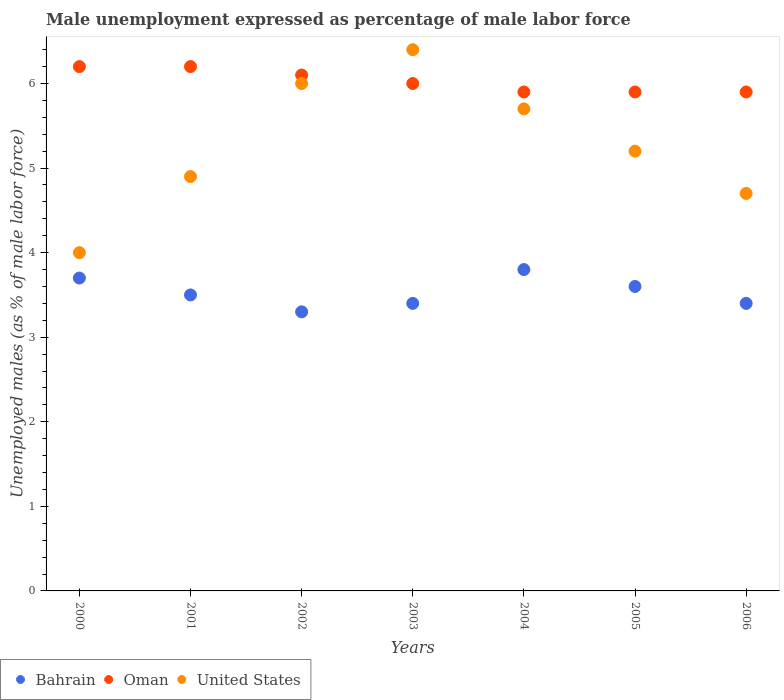How many different coloured dotlines are there?
Your response must be concise. 3. Is the number of dotlines equal to the number of legend labels?
Provide a succinct answer. Yes. What is the unemployment in males in in United States in 2004?
Ensure brevity in your answer.  5.7. Across all years, what is the maximum unemployment in males in in Bahrain?
Give a very brief answer. 3.8. In which year was the unemployment in males in in Bahrain maximum?
Keep it short and to the point. 2004. In which year was the unemployment in males in in Bahrain minimum?
Provide a short and direct response. 2002. What is the total unemployment in males in in Oman in the graph?
Give a very brief answer. 42.2. What is the difference between the unemployment in males in in Bahrain in 2000 and that in 2006?
Your response must be concise. 0.3. What is the difference between the unemployment in males in in Bahrain in 2002 and the unemployment in males in in United States in 2005?
Make the answer very short. -1.9. What is the average unemployment in males in in Oman per year?
Provide a succinct answer. 6.03. In the year 2003, what is the difference between the unemployment in males in in Bahrain and unemployment in males in in United States?
Ensure brevity in your answer.  -3. What is the ratio of the unemployment in males in in United States in 2003 to that in 2006?
Your answer should be compact. 1.36. What is the difference between the highest and the second highest unemployment in males in in United States?
Offer a terse response. 0.4. What is the difference between the highest and the lowest unemployment in males in in Bahrain?
Keep it short and to the point. 0.5. In how many years, is the unemployment in males in in Bahrain greater than the average unemployment in males in in Bahrain taken over all years?
Ensure brevity in your answer.  3. Is the sum of the unemployment in males in in Bahrain in 2003 and 2004 greater than the maximum unemployment in males in in United States across all years?
Offer a terse response. Yes. Is it the case that in every year, the sum of the unemployment in males in in United States and unemployment in males in in Bahrain  is greater than the unemployment in males in in Oman?
Your response must be concise. Yes. Does the unemployment in males in in Bahrain monotonically increase over the years?
Offer a very short reply. No. Is the unemployment in males in in Oman strictly less than the unemployment in males in in United States over the years?
Provide a succinct answer. No. How many dotlines are there?
Provide a short and direct response. 3. How many years are there in the graph?
Keep it short and to the point. 7. What is the difference between two consecutive major ticks on the Y-axis?
Make the answer very short. 1. How many legend labels are there?
Offer a very short reply. 3. How are the legend labels stacked?
Provide a short and direct response. Horizontal. What is the title of the graph?
Your answer should be very brief. Male unemployment expressed as percentage of male labor force. What is the label or title of the Y-axis?
Provide a short and direct response. Unemployed males (as % of male labor force). What is the Unemployed males (as % of male labor force) in Bahrain in 2000?
Your answer should be very brief. 3.7. What is the Unemployed males (as % of male labor force) of Oman in 2000?
Keep it short and to the point. 6.2. What is the Unemployed males (as % of male labor force) of Bahrain in 2001?
Offer a terse response. 3.5. What is the Unemployed males (as % of male labor force) in Oman in 2001?
Make the answer very short. 6.2. What is the Unemployed males (as % of male labor force) of United States in 2001?
Make the answer very short. 4.9. What is the Unemployed males (as % of male labor force) of Bahrain in 2002?
Keep it short and to the point. 3.3. What is the Unemployed males (as % of male labor force) in Oman in 2002?
Your answer should be compact. 6.1. What is the Unemployed males (as % of male labor force) of United States in 2002?
Provide a short and direct response. 6. What is the Unemployed males (as % of male labor force) in Bahrain in 2003?
Provide a short and direct response. 3.4. What is the Unemployed males (as % of male labor force) in Oman in 2003?
Offer a terse response. 6. What is the Unemployed males (as % of male labor force) in United States in 2003?
Provide a short and direct response. 6.4. What is the Unemployed males (as % of male labor force) of Bahrain in 2004?
Give a very brief answer. 3.8. What is the Unemployed males (as % of male labor force) in Oman in 2004?
Your response must be concise. 5.9. What is the Unemployed males (as % of male labor force) of United States in 2004?
Give a very brief answer. 5.7. What is the Unemployed males (as % of male labor force) in Bahrain in 2005?
Offer a very short reply. 3.6. What is the Unemployed males (as % of male labor force) in Oman in 2005?
Your response must be concise. 5.9. What is the Unemployed males (as % of male labor force) of United States in 2005?
Your answer should be very brief. 5.2. What is the Unemployed males (as % of male labor force) of Bahrain in 2006?
Keep it short and to the point. 3.4. What is the Unemployed males (as % of male labor force) in Oman in 2006?
Provide a succinct answer. 5.9. What is the Unemployed males (as % of male labor force) in United States in 2006?
Your answer should be very brief. 4.7. Across all years, what is the maximum Unemployed males (as % of male labor force) in Bahrain?
Your answer should be compact. 3.8. Across all years, what is the maximum Unemployed males (as % of male labor force) in Oman?
Ensure brevity in your answer.  6.2. Across all years, what is the maximum Unemployed males (as % of male labor force) in United States?
Provide a succinct answer. 6.4. Across all years, what is the minimum Unemployed males (as % of male labor force) of Bahrain?
Offer a very short reply. 3.3. Across all years, what is the minimum Unemployed males (as % of male labor force) in Oman?
Keep it short and to the point. 5.9. Across all years, what is the minimum Unemployed males (as % of male labor force) of United States?
Offer a terse response. 4. What is the total Unemployed males (as % of male labor force) in Bahrain in the graph?
Your response must be concise. 24.7. What is the total Unemployed males (as % of male labor force) of Oman in the graph?
Offer a terse response. 42.2. What is the total Unemployed males (as % of male labor force) in United States in the graph?
Offer a terse response. 36.9. What is the difference between the Unemployed males (as % of male labor force) in Bahrain in 2000 and that in 2003?
Your answer should be compact. 0.3. What is the difference between the Unemployed males (as % of male labor force) of Oman in 2000 and that in 2003?
Keep it short and to the point. 0.2. What is the difference between the Unemployed males (as % of male labor force) in Oman in 2000 and that in 2004?
Offer a very short reply. 0.3. What is the difference between the Unemployed males (as % of male labor force) of United States in 2000 and that in 2004?
Your response must be concise. -1.7. What is the difference between the Unemployed males (as % of male labor force) in Bahrain in 2000 and that in 2005?
Make the answer very short. 0.1. What is the difference between the Unemployed males (as % of male labor force) in Oman in 2000 and that in 2005?
Your answer should be very brief. 0.3. What is the difference between the Unemployed males (as % of male labor force) of United States in 2000 and that in 2005?
Offer a terse response. -1.2. What is the difference between the Unemployed males (as % of male labor force) of United States in 2000 and that in 2006?
Your answer should be very brief. -0.7. What is the difference between the Unemployed males (as % of male labor force) of Oman in 2001 and that in 2002?
Your answer should be very brief. 0.1. What is the difference between the Unemployed males (as % of male labor force) in United States in 2001 and that in 2002?
Keep it short and to the point. -1.1. What is the difference between the Unemployed males (as % of male labor force) of Bahrain in 2001 and that in 2003?
Your response must be concise. 0.1. What is the difference between the Unemployed males (as % of male labor force) in United States in 2001 and that in 2003?
Your answer should be very brief. -1.5. What is the difference between the Unemployed males (as % of male labor force) of Oman in 2001 and that in 2005?
Your answer should be compact. 0.3. What is the difference between the Unemployed males (as % of male labor force) of United States in 2001 and that in 2006?
Your response must be concise. 0.2. What is the difference between the Unemployed males (as % of male labor force) of Bahrain in 2002 and that in 2003?
Offer a very short reply. -0.1. What is the difference between the Unemployed males (as % of male labor force) in Oman in 2002 and that in 2003?
Offer a very short reply. 0.1. What is the difference between the Unemployed males (as % of male labor force) of United States in 2002 and that in 2003?
Offer a very short reply. -0.4. What is the difference between the Unemployed males (as % of male labor force) of Bahrain in 2002 and that in 2004?
Keep it short and to the point. -0.5. What is the difference between the Unemployed males (as % of male labor force) of United States in 2002 and that in 2004?
Provide a short and direct response. 0.3. What is the difference between the Unemployed males (as % of male labor force) of Bahrain in 2002 and that in 2005?
Make the answer very short. -0.3. What is the difference between the Unemployed males (as % of male labor force) in United States in 2002 and that in 2005?
Your response must be concise. 0.8. What is the difference between the Unemployed males (as % of male labor force) of Oman in 2002 and that in 2006?
Your response must be concise. 0.2. What is the difference between the Unemployed males (as % of male labor force) in Bahrain in 2003 and that in 2004?
Your answer should be very brief. -0.4. What is the difference between the Unemployed males (as % of male labor force) in Oman in 2003 and that in 2004?
Your response must be concise. 0.1. What is the difference between the Unemployed males (as % of male labor force) of United States in 2003 and that in 2005?
Offer a very short reply. 1.2. What is the difference between the Unemployed males (as % of male labor force) of United States in 2003 and that in 2006?
Offer a very short reply. 1.7. What is the difference between the Unemployed males (as % of male labor force) of United States in 2004 and that in 2005?
Provide a succinct answer. 0.5. What is the difference between the Unemployed males (as % of male labor force) in Bahrain in 2004 and that in 2006?
Give a very brief answer. 0.4. What is the difference between the Unemployed males (as % of male labor force) in Oman in 2004 and that in 2006?
Ensure brevity in your answer.  0. What is the difference between the Unemployed males (as % of male labor force) in United States in 2005 and that in 2006?
Offer a terse response. 0.5. What is the difference between the Unemployed males (as % of male labor force) in Bahrain in 2000 and the Unemployed males (as % of male labor force) in Oman in 2002?
Keep it short and to the point. -2.4. What is the difference between the Unemployed males (as % of male labor force) of Bahrain in 2000 and the Unemployed males (as % of male labor force) of United States in 2003?
Give a very brief answer. -2.7. What is the difference between the Unemployed males (as % of male labor force) of Bahrain in 2000 and the Unemployed males (as % of male labor force) of United States in 2004?
Offer a terse response. -2. What is the difference between the Unemployed males (as % of male labor force) in Oman in 2000 and the Unemployed males (as % of male labor force) in United States in 2006?
Provide a succinct answer. 1.5. What is the difference between the Unemployed males (as % of male labor force) in Oman in 2001 and the Unemployed males (as % of male labor force) in United States in 2002?
Provide a succinct answer. 0.2. What is the difference between the Unemployed males (as % of male labor force) of Bahrain in 2001 and the Unemployed males (as % of male labor force) of Oman in 2003?
Ensure brevity in your answer.  -2.5. What is the difference between the Unemployed males (as % of male labor force) in Bahrain in 2001 and the Unemployed males (as % of male labor force) in United States in 2003?
Make the answer very short. -2.9. What is the difference between the Unemployed males (as % of male labor force) of Bahrain in 2001 and the Unemployed males (as % of male labor force) of Oman in 2004?
Make the answer very short. -2.4. What is the difference between the Unemployed males (as % of male labor force) in Bahrain in 2001 and the Unemployed males (as % of male labor force) in United States in 2004?
Your answer should be compact. -2.2. What is the difference between the Unemployed males (as % of male labor force) of Oman in 2001 and the Unemployed males (as % of male labor force) of United States in 2004?
Your answer should be compact. 0.5. What is the difference between the Unemployed males (as % of male labor force) in Bahrain in 2001 and the Unemployed males (as % of male labor force) in Oman in 2005?
Provide a short and direct response. -2.4. What is the difference between the Unemployed males (as % of male labor force) in Oman in 2001 and the Unemployed males (as % of male labor force) in United States in 2006?
Provide a short and direct response. 1.5. What is the difference between the Unemployed males (as % of male labor force) of Bahrain in 2002 and the Unemployed males (as % of male labor force) of Oman in 2003?
Your answer should be very brief. -2.7. What is the difference between the Unemployed males (as % of male labor force) of Bahrain in 2002 and the Unemployed males (as % of male labor force) of United States in 2003?
Your answer should be compact. -3.1. What is the difference between the Unemployed males (as % of male labor force) in Bahrain in 2002 and the Unemployed males (as % of male labor force) in United States in 2004?
Offer a very short reply. -2.4. What is the difference between the Unemployed males (as % of male labor force) in Bahrain in 2002 and the Unemployed males (as % of male labor force) in Oman in 2005?
Provide a short and direct response. -2.6. What is the difference between the Unemployed males (as % of male labor force) in Oman in 2002 and the Unemployed males (as % of male labor force) in United States in 2006?
Offer a very short reply. 1.4. What is the difference between the Unemployed males (as % of male labor force) in Oman in 2003 and the Unemployed males (as % of male labor force) in United States in 2004?
Give a very brief answer. 0.3. What is the difference between the Unemployed males (as % of male labor force) in Bahrain in 2003 and the Unemployed males (as % of male labor force) in United States in 2006?
Your answer should be compact. -1.3. What is the difference between the Unemployed males (as % of male labor force) in Bahrain in 2004 and the Unemployed males (as % of male labor force) in Oman in 2006?
Provide a short and direct response. -2.1. What is the difference between the Unemployed males (as % of male labor force) of Oman in 2004 and the Unemployed males (as % of male labor force) of United States in 2006?
Your answer should be compact. 1.2. What is the difference between the Unemployed males (as % of male labor force) in Bahrain in 2005 and the Unemployed males (as % of male labor force) in Oman in 2006?
Offer a terse response. -2.3. What is the difference between the Unemployed males (as % of male labor force) in Bahrain in 2005 and the Unemployed males (as % of male labor force) in United States in 2006?
Give a very brief answer. -1.1. What is the average Unemployed males (as % of male labor force) in Bahrain per year?
Your answer should be compact. 3.53. What is the average Unemployed males (as % of male labor force) of Oman per year?
Your answer should be very brief. 6.03. What is the average Unemployed males (as % of male labor force) in United States per year?
Make the answer very short. 5.27. In the year 2000, what is the difference between the Unemployed males (as % of male labor force) in Bahrain and Unemployed males (as % of male labor force) in United States?
Keep it short and to the point. -0.3. In the year 2000, what is the difference between the Unemployed males (as % of male labor force) in Oman and Unemployed males (as % of male labor force) in United States?
Offer a very short reply. 2.2. In the year 2001, what is the difference between the Unemployed males (as % of male labor force) in Bahrain and Unemployed males (as % of male labor force) in Oman?
Your response must be concise. -2.7. In the year 2001, what is the difference between the Unemployed males (as % of male labor force) of Oman and Unemployed males (as % of male labor force) of United States?
Your response must be concise. 1.3. In the year 2002, what is the difference between the Unemployed males (as % of male labor force) of Bahrain and Unemployed males (as % of male labor force) of United States?
Make the answer very short. -2.7. In the year 2002, what is the difference between the Unemployed males (as % of male labor force) in Oman and Unemployed males (as % of male labor force) in United States?
Keep it short and to the point. 0.1. In the year 2003, what is the difference between the Unemployed males (as % of male labor force) of Bahrain and Unemployed males (as % of male labor force) of Oman?
Offer a terse response. -2.6. In the year 2003, what is the difference between the Unemployed males (as % of male labor force) of Bahrain and Unemployed males (as % of male labor force) of United States?
Your answer should be very brief. -3. In the year 2003, what is the difference between the Unemployed males (as % of male labor force) in Oman and Unemployed males (as % of male labor force) in United States?
Give a very brief answer. -0.4. In the year 2004, what is the difference between the Unemployed males (as % of male labor force) of Bahrain and Unemployed males (as % of male labor force) of United States?
Your response must be concise. -1.9. In the year 2006, what is the difference between the Unemployed males (as % of male labor force) in Bahrain and Unemployed males (as % of male labor force) in Oman?
Your answer should be very brief. -2.5. In the year 2006, what is the difference between the Unemployed males (as % of male labor force) of Bahrain and Unemployed males (as % of male labor force) of United States?
Ensure brevity in your answer.  -1.3. What is the ratio of the Unemployed males (as % of male labor force) of Bahrain in 2000 to that in 2001?
Give a very brief answer. 1.06. What is the ratio of the Unemployed males (as % of male labor force) in United States in 2000 to that in 2001?
Your answer should be compact. 0.82. What is the ratio of the Unemployed males (as % of male labor force) of Bahrain in 2000 to that in 2002?
Your response must be concise. 1.12. What is the ratio of the Unemployed males (as % of male labor force) in Oman in 2000 to that in 2002?
Make the answer very short. 1.02. What is the ratio of the Unemployed males (as % of male labor force) in Bahrain in 2000 to that in 2003?
Your response must be concise. 1.09. What is the ratio of the Unemployed males (as % of male labor force) of Oman in 2000 to that in 2003?
Offer a terse response. 1.03. What is the ratio of the Unemployed males (as % of male labor force) in Bahrain in 2000 to that in 2004?
Your answer should be very brief. 0.97. What is the ratio of the Unemployed males (as % of male labor force) in Oman in 2000 to that in 2004?
Ensure brevity in your answer.  1.05. What is the ratio of the Unemployed males (as % of male labor force) of United States in 2000 to that in 2004?
Offer a very short reply. 0.7. What is the ratio of the Unemployed males (as % of male labor force) of Bahrain in 2000 to that in 2005?
Offer a very short reply. 1.03. What is the ratio of the Unemployed males (as % of male labor force) in Oman in 2000 to that in 2005?
Offer a very short reply. 1.05. What is the ratio of the Unemployed males (as % of male labor force) in United States in 2000 to that in 2005?
Keep it short and to the point. 0.77. What is the ratio of the Unemployed males (as % of male labor force) of Bahrain in 2000 to that in 2006?
Make the answer very short. 1.09. What is the ratio of the Unemployed males (as % of male labor force) of Oman in 2000 to that in 2006?
Offer a terse response. 1.05. What is the ratio of the Unemployed males (as % of male labor force) of United States in 2000 to that in 2006?
Give a very brief answer. 0.85. What is the ratio of the Unemployed males (as % of male labor force) of Bahrain in 2001 to that in 2002?
Make the answer very short. 1.06. What is the ratio of the Unemployed males (as % of male labor force) in Oman in 2001 to that in 2002?
Your answer should be very brief. 1.02. What is the ratio of the Unemployed males (as % of male labor force) of United States in 2001 to that in 2002?
Provide a succinct answer. 0.82. What is the ratio of the Unemployed males (as % of male labor force) of Bahrain in 2001 to that in 2003?
Provide a succinct answer. 1.03. What is the ratio of the Unemployed males (as % of male labor force) of Oman in 2001 to that in 2003?
Your answer should be very brief. 1.03. What is the ratio of the Unemployed males (as % of male labor force) of United States in 2001 to that in 2003?
Make the answer very short. 0.77. What is the ratio of the Unemployed males (as % of male labor force) in Bahrain in 2001 to that in 2004?
Offer a very short reply. 0.92. What is the ratio of the Unemployed males (as % of male labor force) in Oman in 2001 to that in 2004?
Provide a succinct answer. 1.05. What is the ratio of the Unemployed males (as % of male labor force) of United States in 2001 to that in 2004?
Offer a very short reply. 0.86. What is the ratio of the Unemployed males (as % of male labor force) in Bahrain in 2001 to that in 2005?
Offer a very short reply. 0.97. What is the ratio of the Unemployed males (as % of male labor force) in Oman in 2001 to that in 2005?
Keep it short and to the point. 1.05. What is the ratio of the Unemployed males (as % of male labor force) of United States in 2001 to that in 2005?
Ensure brevity in your answer.  0.94. What is the ratio of the Unemployed males (as % of male labor force) in Bahrain in 2001 to that in 2006?
Provide a succinct answer. 1.03. What is the ratio of the Unemployed males (as % of male labor force) of Oman in 2001 to that in 2006?
Your response must be concise. 1.05. What is the ratio of the Unemployed males (as % of male labor force) of United States in 2001 to that in 2006?
Your response must be concise. 1.04. What is the ratio of the Unemployed males (as % of male labor force) in Bahrain in 2002 to that in 2003?
Offer a terse response. 0.97. What is the ratio of the Unemployed males (as % of male labor force) of Oman in 2002 to that in 2003?
Provide a short and direct response. 1.02. What is the ratio of the Unemployed males (as % of male labor force) of Bahrain in 2002 to that in 2004?
Your response must be concise. 0.87. What is the ratio of the Unemployed males (as % of male labor force) in Oman in 2002 to that in 2004?
Offer a very short reply. 1.03. What is the ratio of the Unemployed males (as % of male labor force) in United States in 2002 to that in 2004?
Give a very brief answer. 1.05. What is the ratio of the Unemployed males (as % of male labor force) in Oman in 2002 to that in 2005?
Keep it short and to the point. 1.03. What is the ratio of the Unemployed males (as % of male labor force) of United States in 2002 to that in 2005?
Your response must be concise. 1.15. What is the ratio of the Unemployed males (as % of male labor force) in Bahrain in 2002 to that in 2006?
Provide a succinct answer. 0.97. What is the ratio of the Unemployed males (as % of male labor force) in Oman in 2002 to that in 2006?
Your answer should be very brief. 1.03. What is the ratio of the Unemployed males (as % of male labor force) in United States in 2002 to that in 2006?
Ensure brevity in your answer.  1.28. What is the ratio of the Unemployed males (as % of male labor force) of Bahrain in 2003 to that in 2004?
Offer a very short reply. 0.89. What is the ratio of the Unemployed males (as % of male labor force) in Oman in 2003 to that in 2004?
Your response must be concise. 1.02. What is the ratio of the Unemployed males (as % of male labor force) in United States in 2003 to that in 2004?
Give a very brief answer. 1.12. What is the ratio of the Unemployed males (as % of male labor force) of Bahrain in 2003 to that in 2005?
Your response must be concise. 0.94. What is the ratio of the Unemployed males (as % of male labor force) of Oman in 2003 to that in 2005?
Offer a terse response. 1.02. What is the ratio of the Unemployed males (as % of male labor force) in United States in 2003 to that in 2005?
Your response must be concise. 1.23. What is the ratio of the Unemployed males (as % of male labor force) of Bahrain in 2003 to that in 2006?
Offer a very short reply. 1. What is the ratio of the Unemployed males (as % of male labor force) of Oman in 2003 to that in 2006?
Provide a short and direct response. 1.02. What is the ratio of the Unemployed males (as % of male labor force) in United States in 2003 to that in 2006?
Your answer should be very brief. 1.36. What is the ratio of the Unemployed males (as % of male labor force) in Bahrain in 2004 to that in 2005?
Your answer should be compact. 1.06. What is the ratio of the Unemployed males (as % of male labor force) in United States in 2004 to that in 2005?
Give a very brief answer. 1.1. What is the ratio of the Unemployed males (as % of male labor force) in Bahrain in 2004 to that in 2006?
Provide a succinct answer. 1.12. What is the ratio of the Unemployed males (as % of male labor force) in United States in 2004 to that in 2006?
Offer a very short reply. 1.21. What is the ratio of the Unemployed males (as % of male labor force) of Bahrain in 2005 to that in 2006?
Ensure brevity in your answer.  1.06. What is the ratio of the Unemployed males (as % of male labor force) of United States in 2005 to that in 2006?
Your answer should be very brief. 1.11. What is the difference between the highest and the second highest Unemployed males (as % of male labor force) in Bahrain?
Provide a succinct answer. 0.1. What is the difference between the highest and the second highest Unemployed males (as % of male labor force) of Oman?
Provide a short and direct response. 0. What is the difference between the highest and the second highest Unemployed males (as % of male labor force) in United States?
Ensure brevity in your answer.  0.4. 